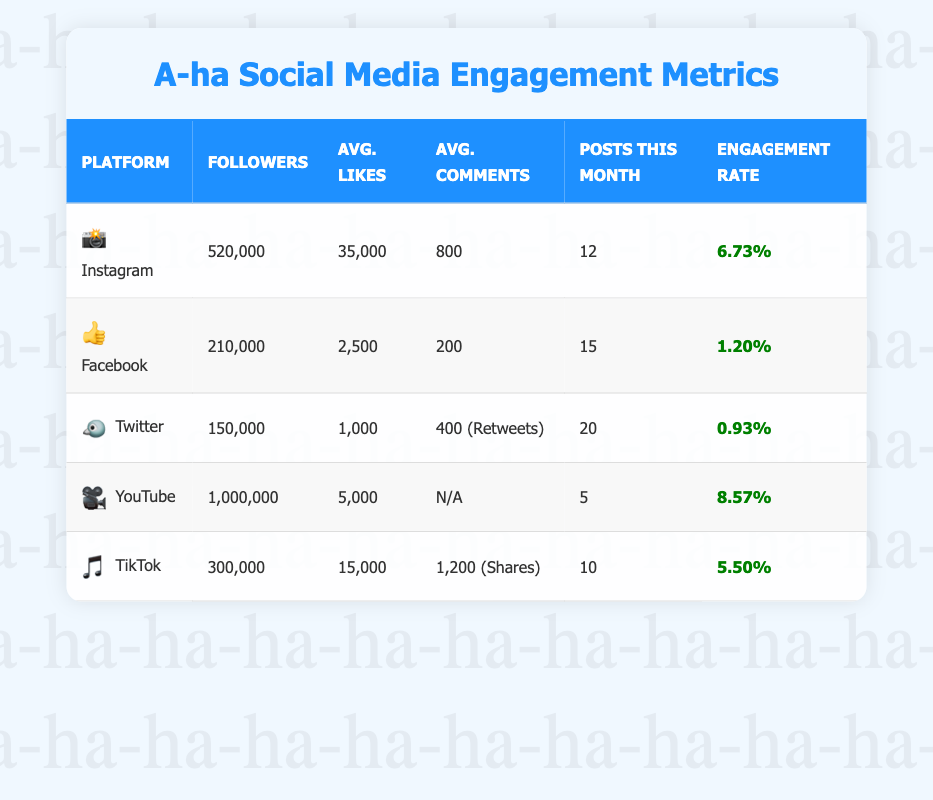What platform has the highest number of followers? By examining the "Followers" column, I see that YouTube has the highest number of followers at 1,000,000.
Answer: YouTube What is the average number of likes on Instagram? The table shows that the average number of likes on Instagram is 35,000.
Answer: 35,000 Which platform has the lowest engagement rate? Looking at the "Engagement Rate" column, I see Facebook has the lowest engagement rate at 1.20%.
Answer: Facebook How many more followers does TikTok have than Twitter? TikTok has 300,000 followers and Twitter has 150,000 followers. The difference is 300,000 - 150,000 = 150,000.
Answer: 150,000 What is the total average likes across all platforms? Adding the average likes from all platforms: 35,000 (Instagram) + 2,500 (Facebook) + 1,000 (Twitter) + 5,000 (YouTube) + 15,000 (TikTok) gives us a total of 58,500. To find the average across 5 platforms, we divide by 5, which results in 58,500 / 5 = 11,700.
Answer: 11,700 Is the engagement rate on YouTube higher than that on Instagram? The engagement rate for YouTube is 8.57% and for Instagram, it is 6.73%. Since 8.57% is greater than 6.73%, the statement is true.
Answer: Yes If we consider only Instagram and TikTok, what is their combined average number of posts this month? Instagram has 12 posts and TikTok has 10 posts. Adding them gives a total of 12 + 10 = 22. To find the average, we divide by 2, which results in 22 / 2 = 11.
Answer: 11 How does the average number of likes on TikTok compare to that on Facebook? The average likes on TikTok is 15,000 while on Facebook it is 2,500. Comparing the two, 15,000 is significantly greater than 2,500.
Answer: TikTok has more likes What is the total number of followers across all platforms? Adding the followers from all platforms: 520,000 (Instagram) + 210,000 (Facebook) + 150,000 (Twitter) + 1,000,000 (YouTube) + 300,000 (TikTok) results in 2,180,000 total followers.
Answer: 2,180,000 Is it true that the average number of comments on Twitter is greater than that on Instagram? Twitter has an average of 400 comments, while Instagram has 800 comments. Since 400 is less than 800, the statement is false.
Answer: No What is the difference in the number of posts this month between Facebook and YouTube? Facebook has 15 posts and YouTube has 5 posts. The difference is 15 - 5 = 10.
Answer: 10 